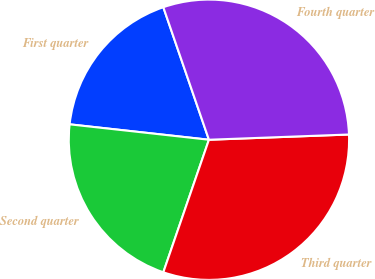<chart> <loc_0><loc_0><loc_500><loc_500><pie_chart><fcel>First quarter<fcel>Second quarter<fcel>Third quarter<fcel>Fourth quarter<nl><fcel>17.97%<fcel>21.48%<fcel>30.87%<fcel>29.68%<nl></chart> 